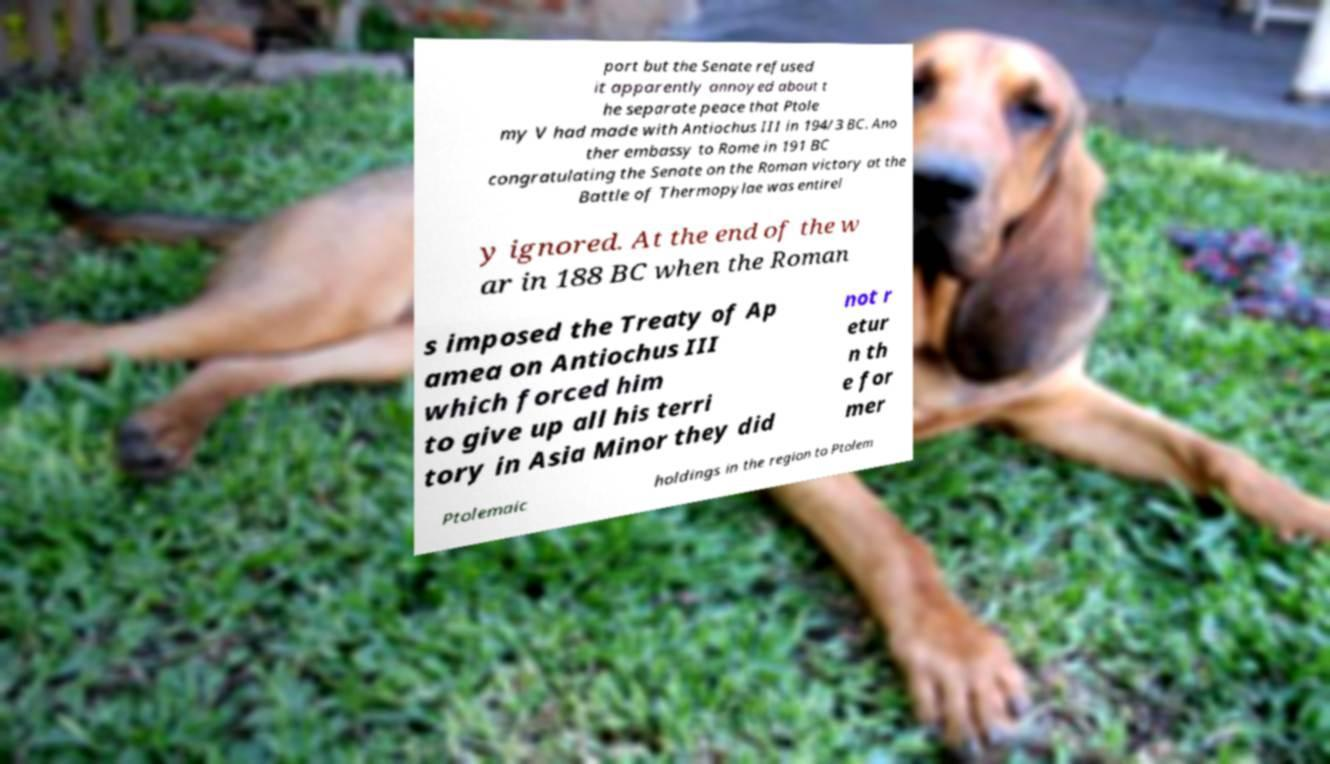For documentation purposes, I need the text within this image transcribed. Could you provide that? port but the Senate refused it apparently annoyed about t he separate peace that Ptole my V had made with Antiochus III in 194/3 BC. Ano ther embassy to Rome in 191 BC congratulating the Senate on the Roman victory at the Battle of Thermopylae was entirel y ignored. At the end of the w ar in 188 BC when the Roman s imposed the Treaty of Ap amea on Antiochus III which forced him to give up all his terri tory in Asia Minor they did not r etur n th e for mer Ptolemaic holdings in the region to Ptolem 